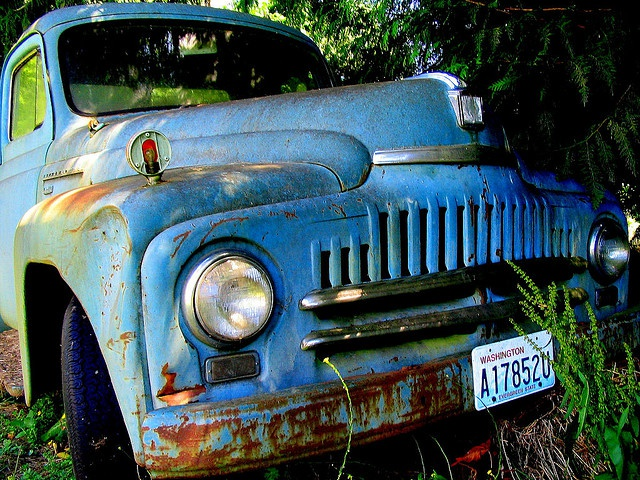Describe the objects in this image and their specific colors. I can see a truck in black, teal, and lightblue tones in this image. 